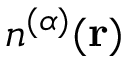Convert formula to latex. <formula><loc_0><loc_0><loc_500><loc_500>n ^ { ( \alpha ) } ( r )</formula> 